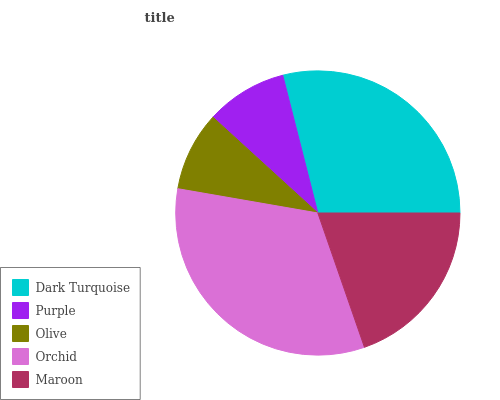Is Olive the minimum?
Answer yes or no. Yes. Is Orchid the maximum?
Answer yes or no. Yes. Is Purple the minimum?
Answer yes or no. No. Is Purple the maximum?
Answer yes or no. No. Is Dark Turquoise greater than Purple?
Answer yes or no. Yes. Is Purple less than Dark Turquoise?
Answer yes or no. Yes. Is Purple greater than Dark Turquoise?
Answer yes or no. No. Is Dark Turquoise less than Purple?
Answer yes or no. No. Is Maroon the high median?
Answer yes or no. Yes. Is Maroon the low median?
Answer yes or no. Yes. Is Dark Turquoise the high median?
Answer yes or no. No. Is Orchid the low median?
Answer yes or no. No. 